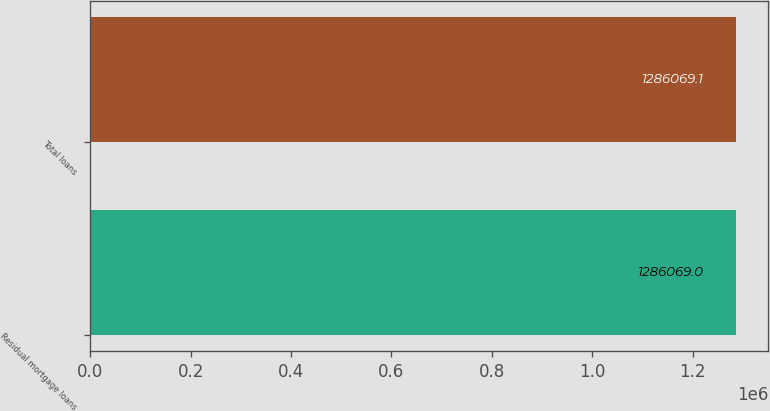Convert chart. <chart><loc_0><loc_0><loc_500><loc_500><bar_chart><fcel>Residual mortgage loans<fcel>Total loans<nl><fcel>1.28607e+06<fcel>1.28607e+06<nl></chart> 